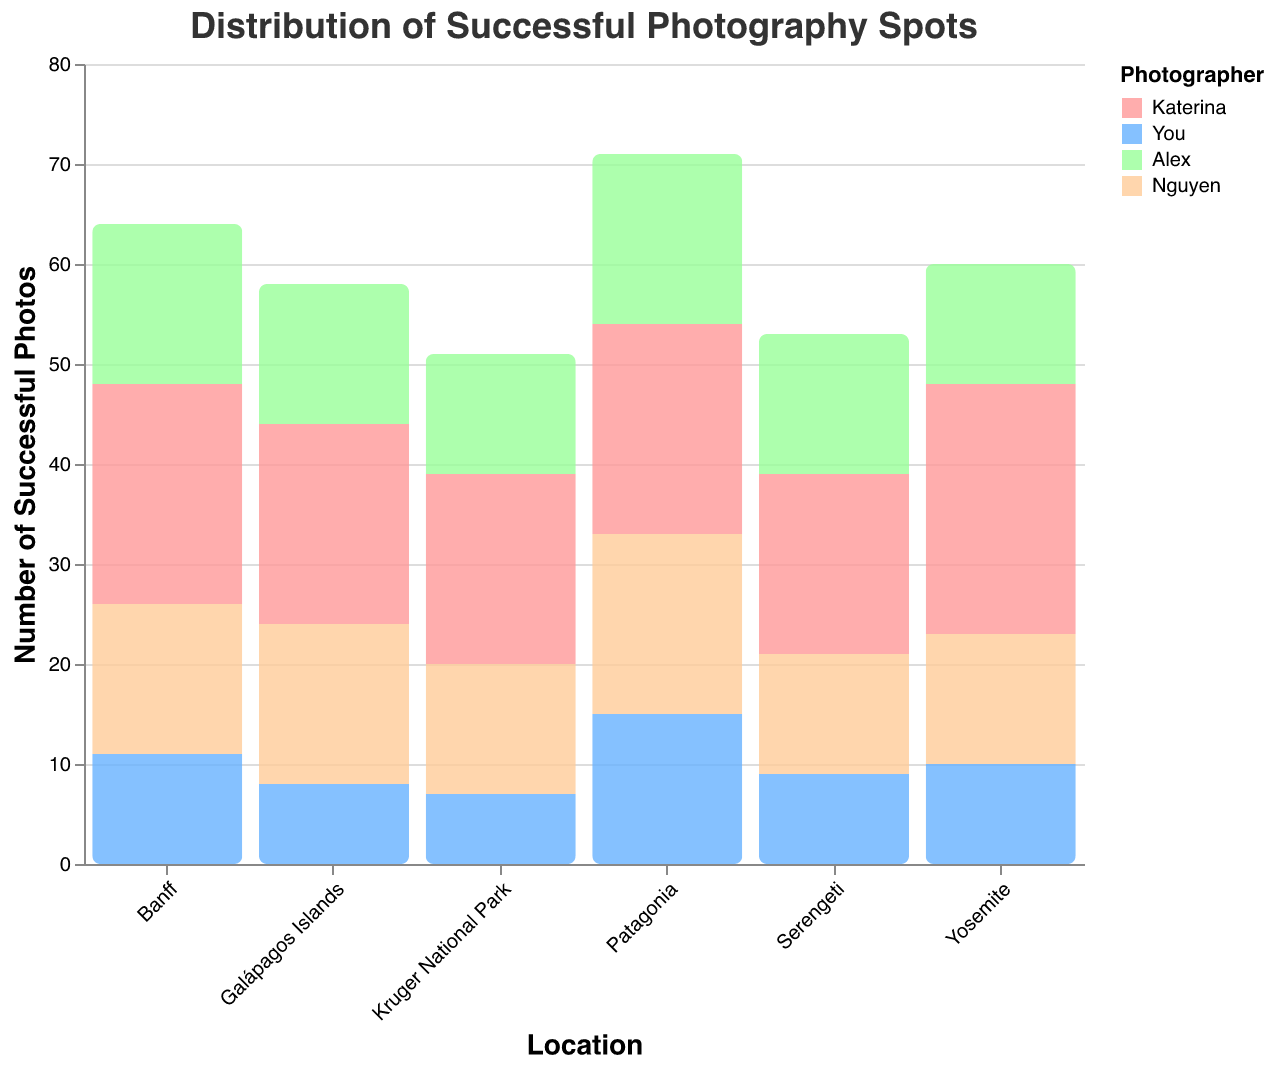What is the title of the figure? The title of the figure is positioned at the top, typically indicating the subject of the data visualization. Here, the title is clearly labeled to describe the content of the figure.
Answer: Distribution of Successful Photography Spots Which location has the highest number of successful photos taken by Katerina? To determine this, look for the tallest bar among Katerina's color in the bar chart, which represents her data. The tallest bar highlighted in her color corresponds to Yosemite.
Answer: Yosemite How do your successful photos in Banff compare to Katerina's? Compare the heights of the bars representing the number of successful photos in Banff for both photographers. Katerina's bar in Banff is taller than yours.
Answer: Yours are fewer Who has the highest number of successful photos in Patagonia? By examining the heights of the bars for each photographer at the location Patagonia, the tallest bar indicates who has the most successful photos. Katerina's bar is the tallest here.
Answer: Katerina What is the total number of successful photos taken by Nguyen? Sum up the heights of Nguyen's bars across all locations (Yosemite, Serengeti, Banff, Galápagos Islands, Kruger National Park, and Patagonia). Nguyen's values are 13, 12, 15, 16, 13, and 18, respectively. The total is 87.
Answer: 87 What’s the average number of successful photos taken by Alex? To determine Alex's average, sum his total number of successful photos across all locations and divide by the number of locations. Alex's values are 12, 14, 16, 14, 12, and 17, resulting in a total of 85. Dividing 85 by 6 locations gives an average of about 14.17.
Answer: 14.17 Which location has the smallest number of successful photos taken by you? Identify the shortest bar among the bars representing your data in the bar chart. The shortest bar for you is in Kruger National Park with 7 successful photos.
Answer: Kruger National Park Considering Katerina, Alex, and Nguyen's top locations, who has the most successful photos in Galápagos Islands? Compare the heights of the bars representing Katerina, Alex, and Nguyen for the Galápagos Islands. Katerina has 20; Alex has 14, and Nguyen has 16, so Katerina has the most.
Answer: Katerina What’s the difference in the number of successful photos between Katerina and you in Yosemite? Subtract the number of successful photos you have in Yosemite from Katerina's number in the same location. Katerina has 25, and you have 10, so the difference is 25 - 10 = 15.
Answer: 15 Who has more successful photos overall in Kruger National Park, Alex or Nguyen? Compare the total heights of the bars representing the number of successful photos in Kruger National Park for both photographers. Alex has 12 and Nguyen has 13, so Nguyen has more.
Answer: Nguyen 